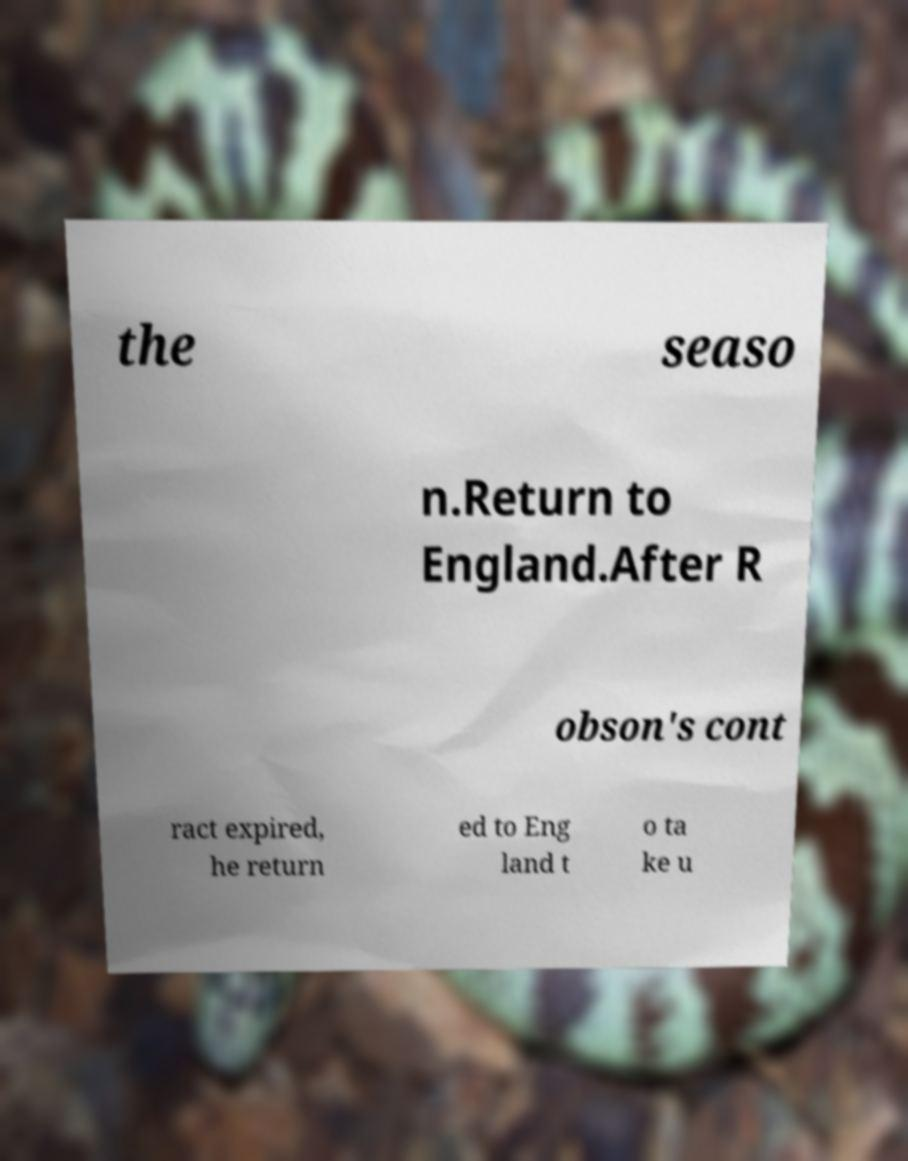There's text embedded in this image that I need extracted. Can you transcribe it verbatim? the seaso n.Return to England.After R obson's cont ract expired, he return ed to Eng land t o ta ke u 